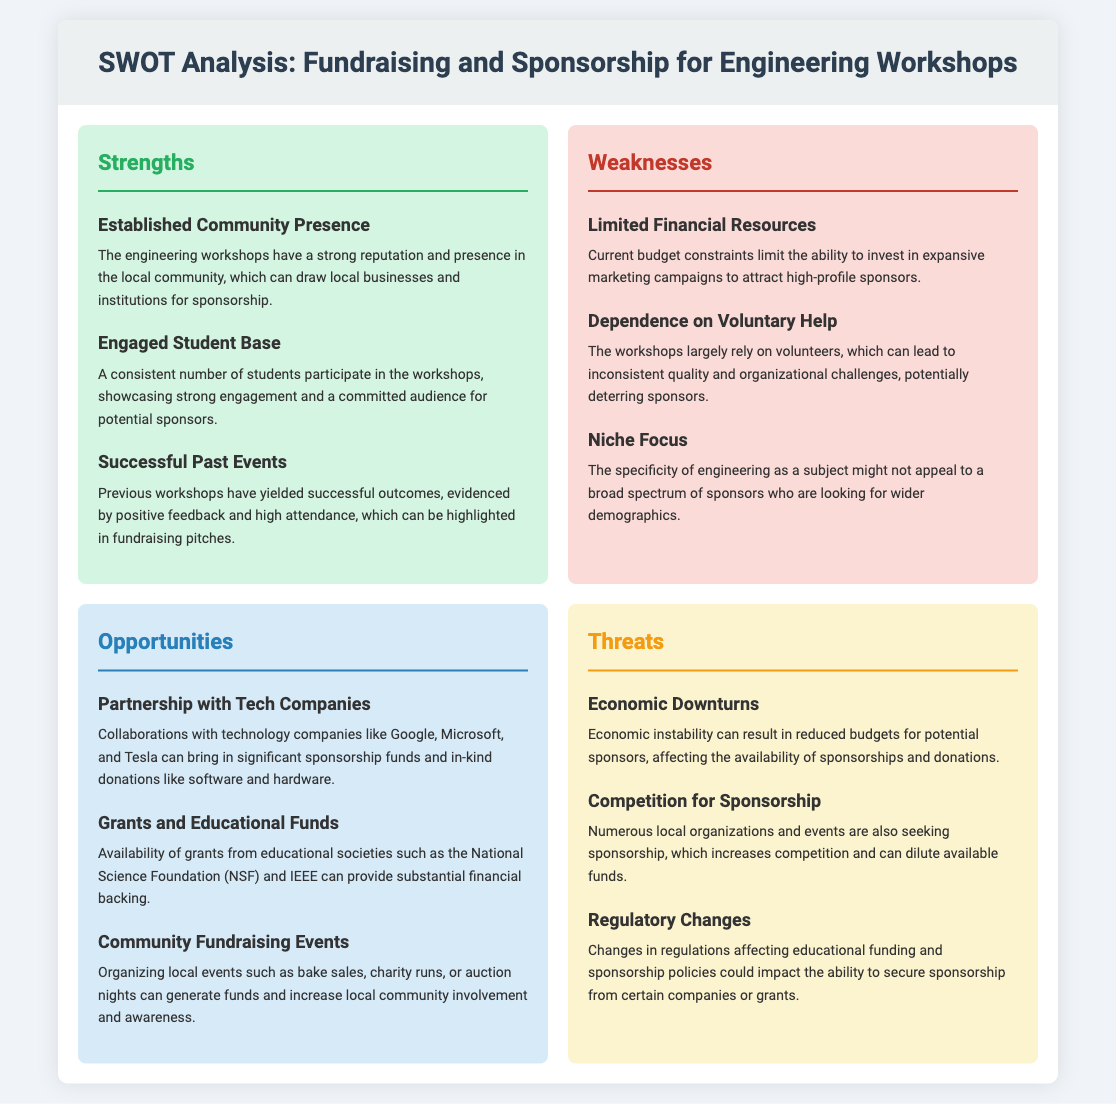What are the strengths of the engineering workshops? The strengths of the engineering workshops include established community presence, engaged student base, and successful past events.
Answer: Established Community Presence, Engaged Student Base, Successful Past Events What is a weakness related to the organizational structure? The organizational structure is affected by the dependence on voluntary help, which can lead to inconsistent quality.
Answer: Dependence on Voluntary Help Which company is suggested for partnerships in opportunities? The SWOT analysis mentions technology companies such as Google, Microsoft, and Tesla for partnerships.
Answer: Google, Microsoft, Tesla How many weaknesses are listed in the document? The document lists three weaknesses regarding fundraising and sponsorship.
Answer: 3 What type of events can generate funds according to the opportunities section? The opportunities section suggests organizing local events like bake sales, charity runs, or auction nights.
Answer: Bake sales, charity runs, auction nights What threat is related to the economy? The document states that economic downturns can impact sponsorship availability.
Answer: Economic Downturns What is one potential source of grants mentioned in the opportunities? The availability of grants from educational societies such as the National Science Foundation (NSF) is mentioned.
Answer: National Science Foundation (NSF) What color represents weaknesses in the SWOT analysis? The weaknesses section is colored in a shade that indicates challenges, specifically a light red/pink.
Answer: Light red/pink What does the threats section discuss about competition? The threats section mentions that competition for sponsorship is increasing among local organizations and events.
Answer: Competition for Sponsorship 